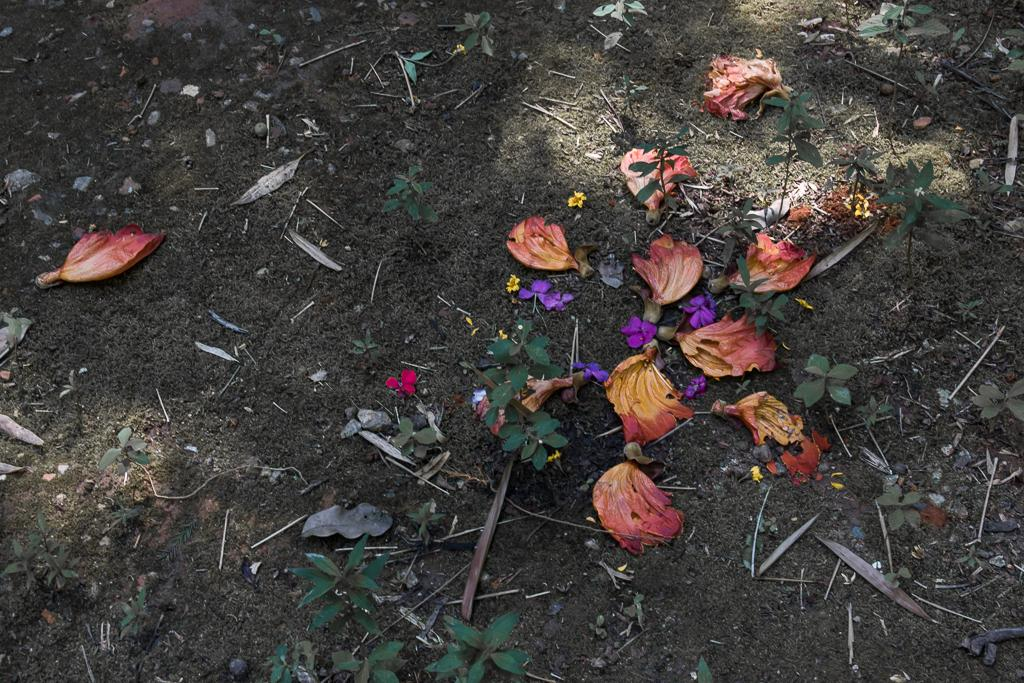What type of living organisms can be seen in the image? Flowers and plants can be seen in the image. Where are the flowers and plants located in the image? The flowers and plants are on the ground in the image. Can you tell me how many snails are crawling on the flowers in the image? There are no snails visible on the flowers in the image. What type of error is present in the image? There is no error present in the image; it is a clear image of flowers and plants. 